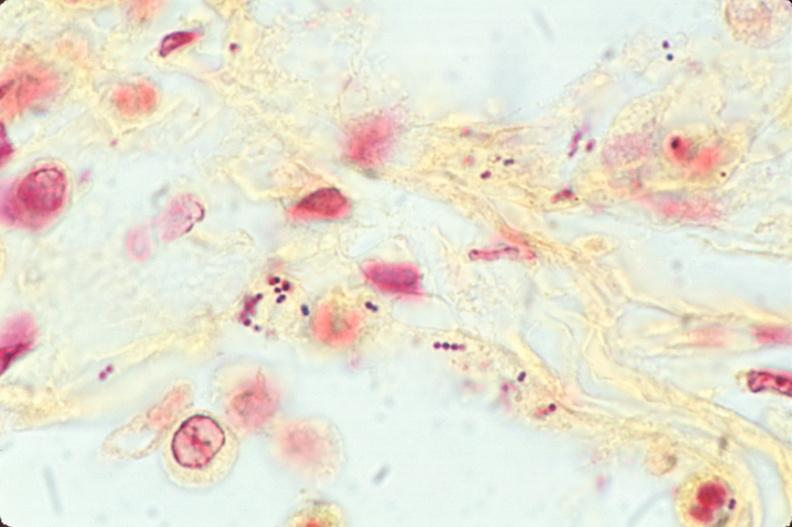what is present?
Answer the question using a single word or phrase. Respiratory 